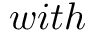Convert formula to latex. <formula><loc_0><loc_0><loc_500><loc_500>w i t h</formula> 